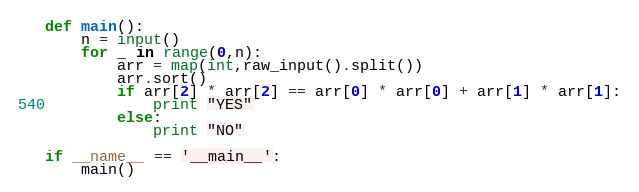Convert code to text. <code><loc_0><loc_0><loc_500><loc_500><_Python_>def main():
    n = input()
    for _ in range(0,n):
        arr = map(int,raw_input().split())
        arr.sort()
        if arr[2] * arr[2] == arr[0] * arr[0] + arr[1] * arr[1]:
            print "YES"
        else:
            print "NO"

if __name__ == '__main__':
    main()</code> 